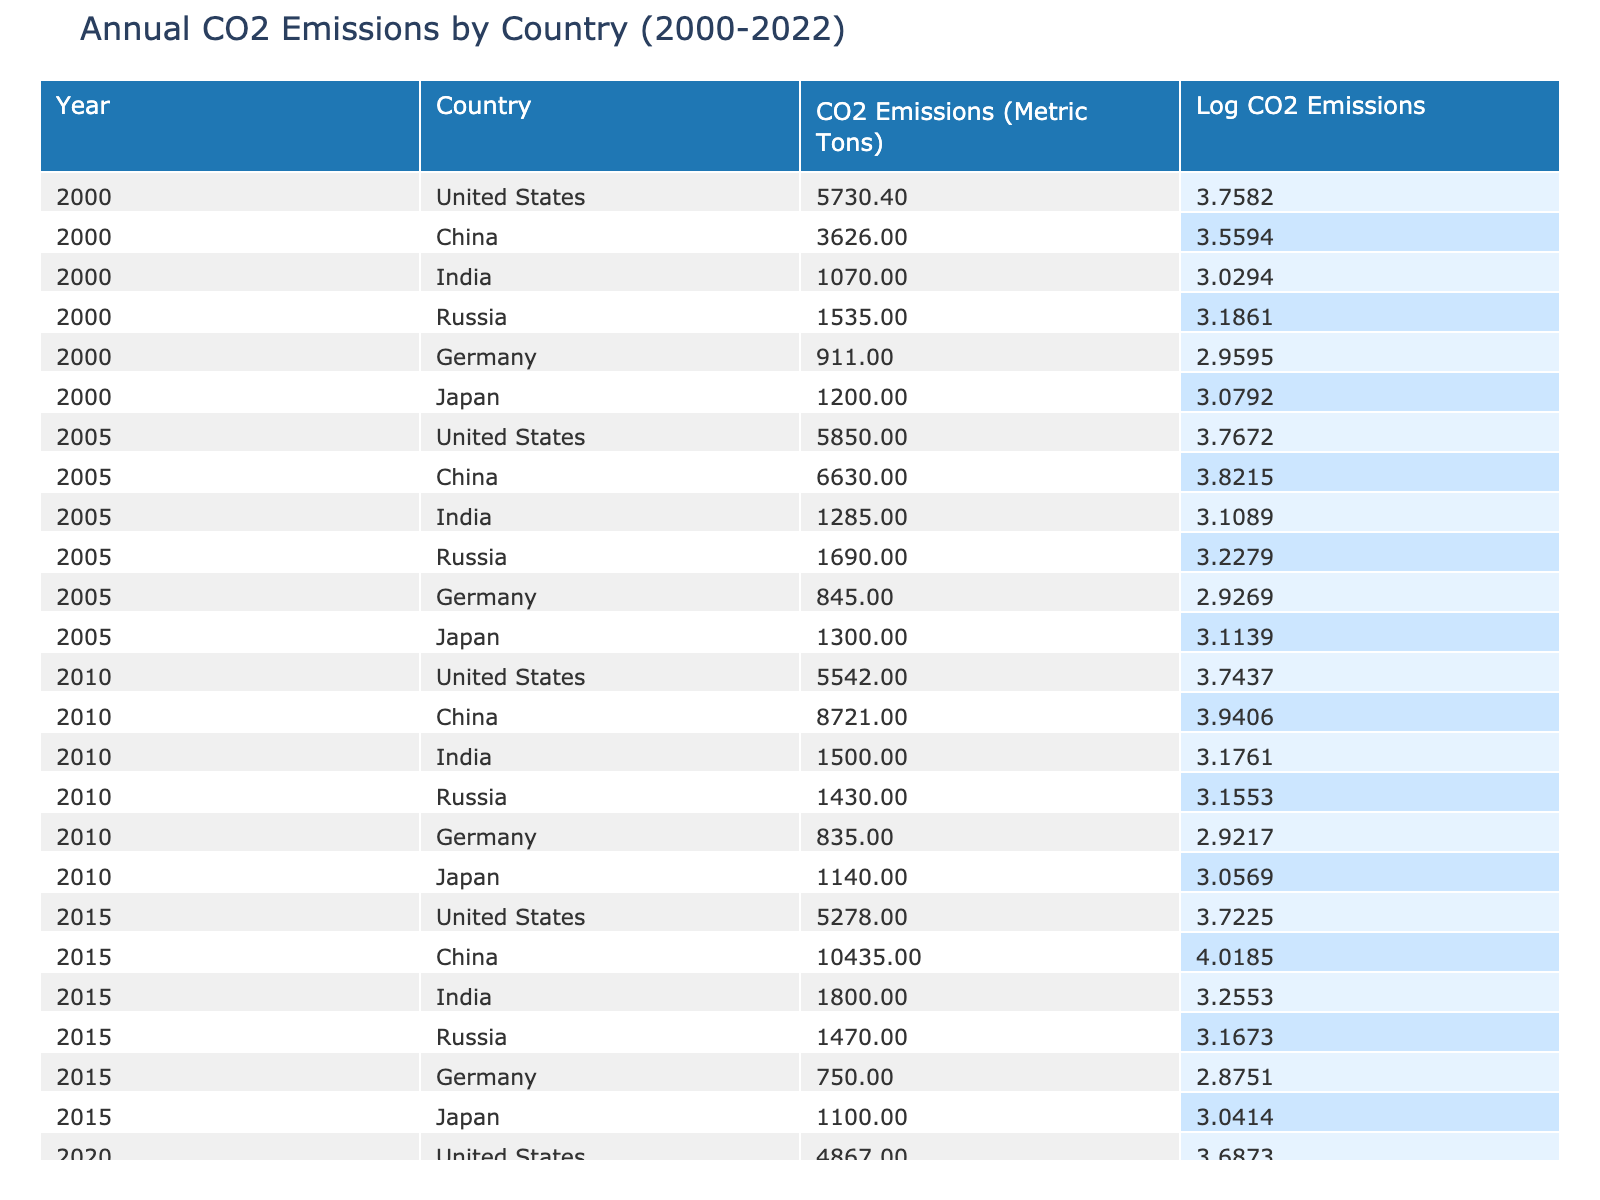What were the CO2 emissions of China in 2010? From the table, I can see that in the year 2010, the CO2 emissions for China were recorded as 8721.00 metric tons.
Answer: 8721.00 What is the range of CO2 emissions for India from 2000 to 2022? To determine the range, I will find the maximum and minimum values of CO2 emissions for India across all years. The minimum is 1070.00 in 2000 and the maximum is 2360.00 in 2022. The range is calculated as 2360.00 - 1070.00 = 1290.00 metric tons.
Answer: 1290.00 Was the CO2 emissions value for Russia in 2015 higher than its emissions in 2010? According to the table, Russia's emissions in 2015 were 1470.00 metric tons and in 2010 it was 1430.00 metric tons. Since 1470.00 is greater than 1430.00, the answer is yes.
Answer: Yes What was the total CO2 emissions of the United States from 2000 to 2022? I will sum the CO2 emissions of the United States for each year listed: 5730.40 (2000) + 5850.00 (2005) + 5542.00 (2010) + 5278.00 (2015) + 4867.00 (2020) + 4716.00 (2022) = 31543.40 metric tons.
Answer: 31543.40 Which country had the highest CO2 emissions in 2022, and what was the amount? By examining the table for the year 2022, I can see that China had the highest CO2 emissions of 12025.00 metric tons.
Answer: China, 12025.00 What was the change in CO2 emissions for Germany from 2000 to 2022? For Germany, the emissions in 2000 were 911.00 metric tons and in 2022 were 610.00 metric tons. The change is calculated as 610.00 - 911.00 = -301.00 metric tons, indicating a decrease.
Answer: -301.00 Is it true that Japan's CO2 emissions were consistently higher than Germany's throughout the provided years? By checking the emissions for each year: 1200.00 (2000) vs. 911.00, 1300.00 (2005) vs. 845.00, 1140.00 (2010) vs. 835.00, 1100.00 (2015) vs. 750.00, 950.00 (2020) vs. 660.00, and 880.00 (2022) vs. 610.00; Japan's emissions were higher in all instances. Thus, the answer is true.
Answer: True What were the average CO2 emissions for China from 2000 to 2022? I need to add China's emissions for each year: 3626.00 (2000) + 6630.00 (2005) + 8721.00 (2010) + 10435.00 (2015) + 10823.00 (2020) + 12025.00 (2022) = 49660.00 metric tons. Then, I divide by 6 years: 49660.00 / 6 ≈ 8276.67 metric tons.
Answer: 8276.67 What was the percentage change in CO2 emissions for the United States from 2000 to 2022? The emissions in 2000 were 5730.40 and in 2022 were 4716.00. The absolute change is 4716.00 - 5730.40 = -1014.40. The percentage change is calculated as (-1014.40 / 5730.40) * 100 ≈ -17.71%.
Answer: -17.71% 